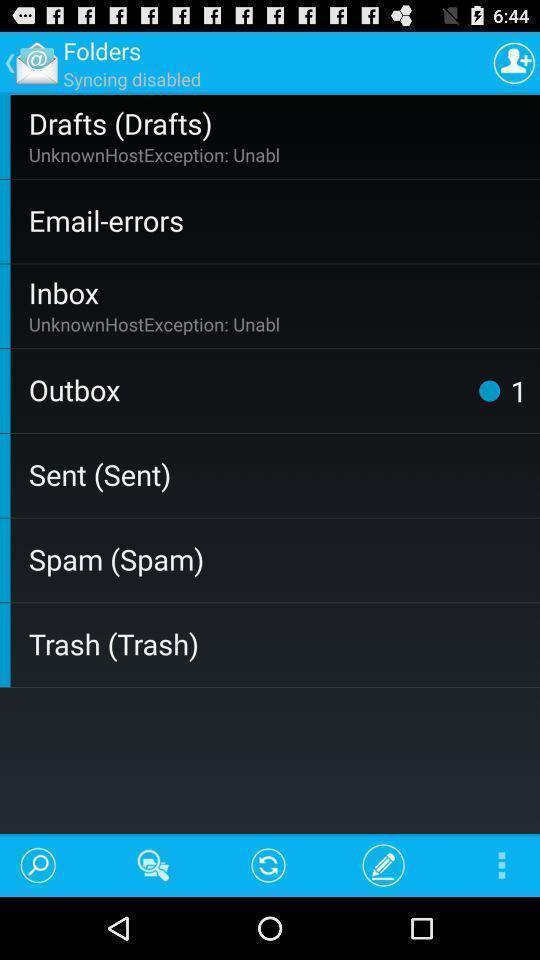Please provide a description for this image. Pop up page showing the options in more menu. 